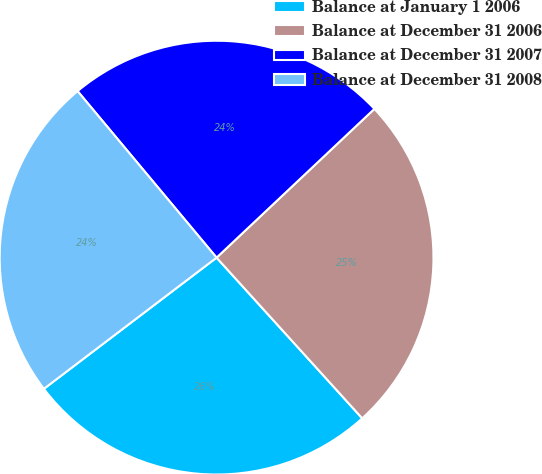Convert chart. <chart><loc_0><loc_0><loc_500><loc_500><pie_chart><fcel>Balance at January 1 2006<fcel>Balance at December 31 2006<fcel>Balance at December 31 2007<fcel>Balance at December 31 2008<nl><fcel>26.38%<fcel>25.31%<fcel>24.04%<fcel>24.27%<nl></chart> 